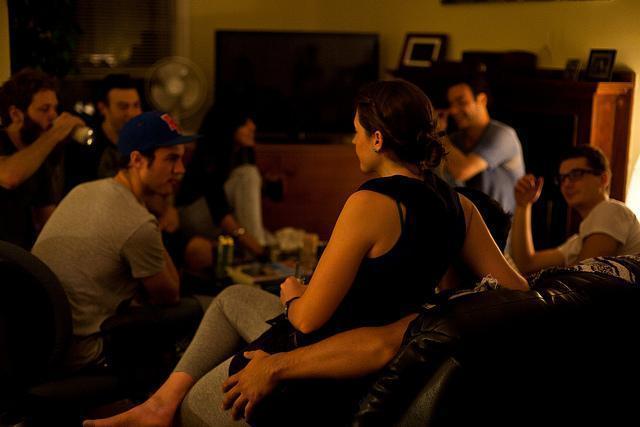How many people?
Give a very brief answer. 8. How many balloons are shown?
Give a very brief answer. 0. How many chairs are in the photo?
Give a very brief answer. 1. How many people can be seen?
Give a very brief answer. 8. 